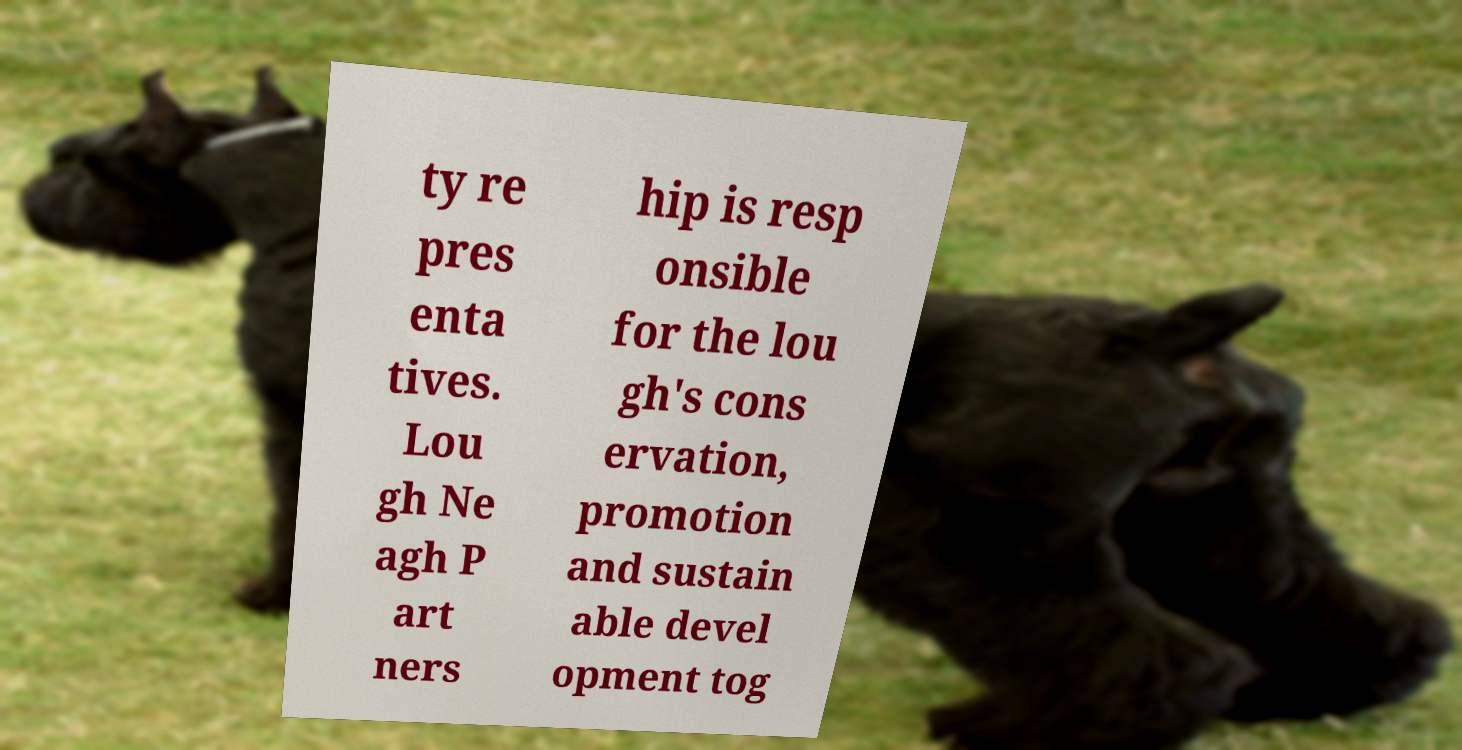What messages or text are displayed in this image? I need them in a readable, typed format. ty re pres enta tives. Lou gh Ne agh P art ners hip is resp onsible for the lou gh's cons ervation, promotion and sustain able devel opment tog 